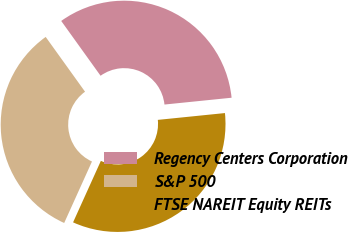Convert chart. <chart><loc_0><loc_0><loc_500><loc_500><pie_chart><fcel>Regency Centers Corporation<fcel>S&P 500<fcel>FTSE NAREIT Equity REITs<nl><fcel>33.3%<fcel>33.33%<fcel>33.37%<nl></chart> 